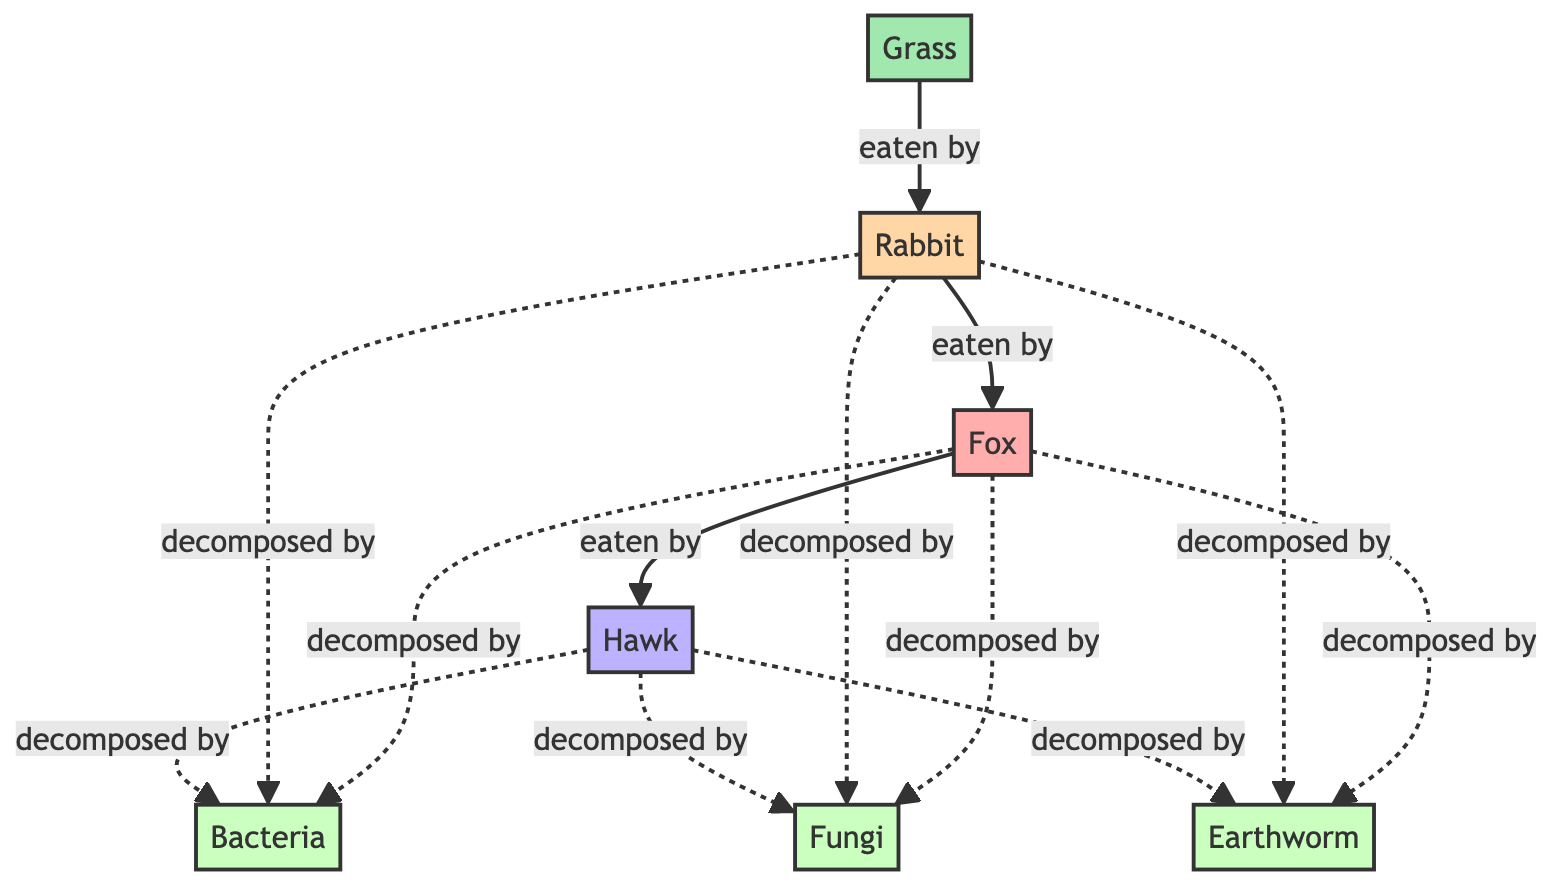What is the producer in this food chain? The diagram shows "Grass" as the only producer, positioned at the beginning of the food chain.
Answer: Grass How many decomposers are represented in the diagram? The diagram lists three decomposers: bacteria, fungi, and earthworm. Hence, a count of these nodes gives us three decomposers.
Answer: 3 What do rabbits eat according to the diagram? From the diagram, the arrow indicates that rabbits eat grass, which is the only direct connection to the rabbit node.
Answer: Grass Which animal is at the top of the food chain? The hawk is shown as the last node in the sequence of consumers, meaning it is the top predator in this food chain.
Answer: Hawk How are decomposers connected in the diagram? The diagram illustrates that bacteria, fungi, and earthworms are connected to multiple consumers (hawk, rabbit, fox) through dashed lines, which represent the decomposition process.
Answer: Dashed lines What is the connection between foxes and decomposers? The fox is shown to be decomposed by three decomposers: bacteria, fungi, and earthworm, as indicated by the connections (dashed lines) from the fox node to each decomposer.
Answer: Bacteria, fungi, earthworm How many edible relationships are displayed for rabbits? In the diagram, rabbits are only shown with one edible relationship, which is eating grass. Hence, there is only a single relationship line leading to the rabbit.
Answer: 1 Which consumers can hawks decompose? Hawks are decomposed by bacteria, fungi, and earthworms according to the diagram, highlighting that the hawk's role feeds into the decomposer cycle at the end of its life.
Answer: Bacteria, fungi, earthworm What type of relationship exists between decomposers and consumers? The dashed lines represent a decomposing relationship between the decomposers and the various consumers (hawk, rabbit, fox), indicating that once these animals die, they are broken down by decomposers.
Answer: Decomposing relationship 